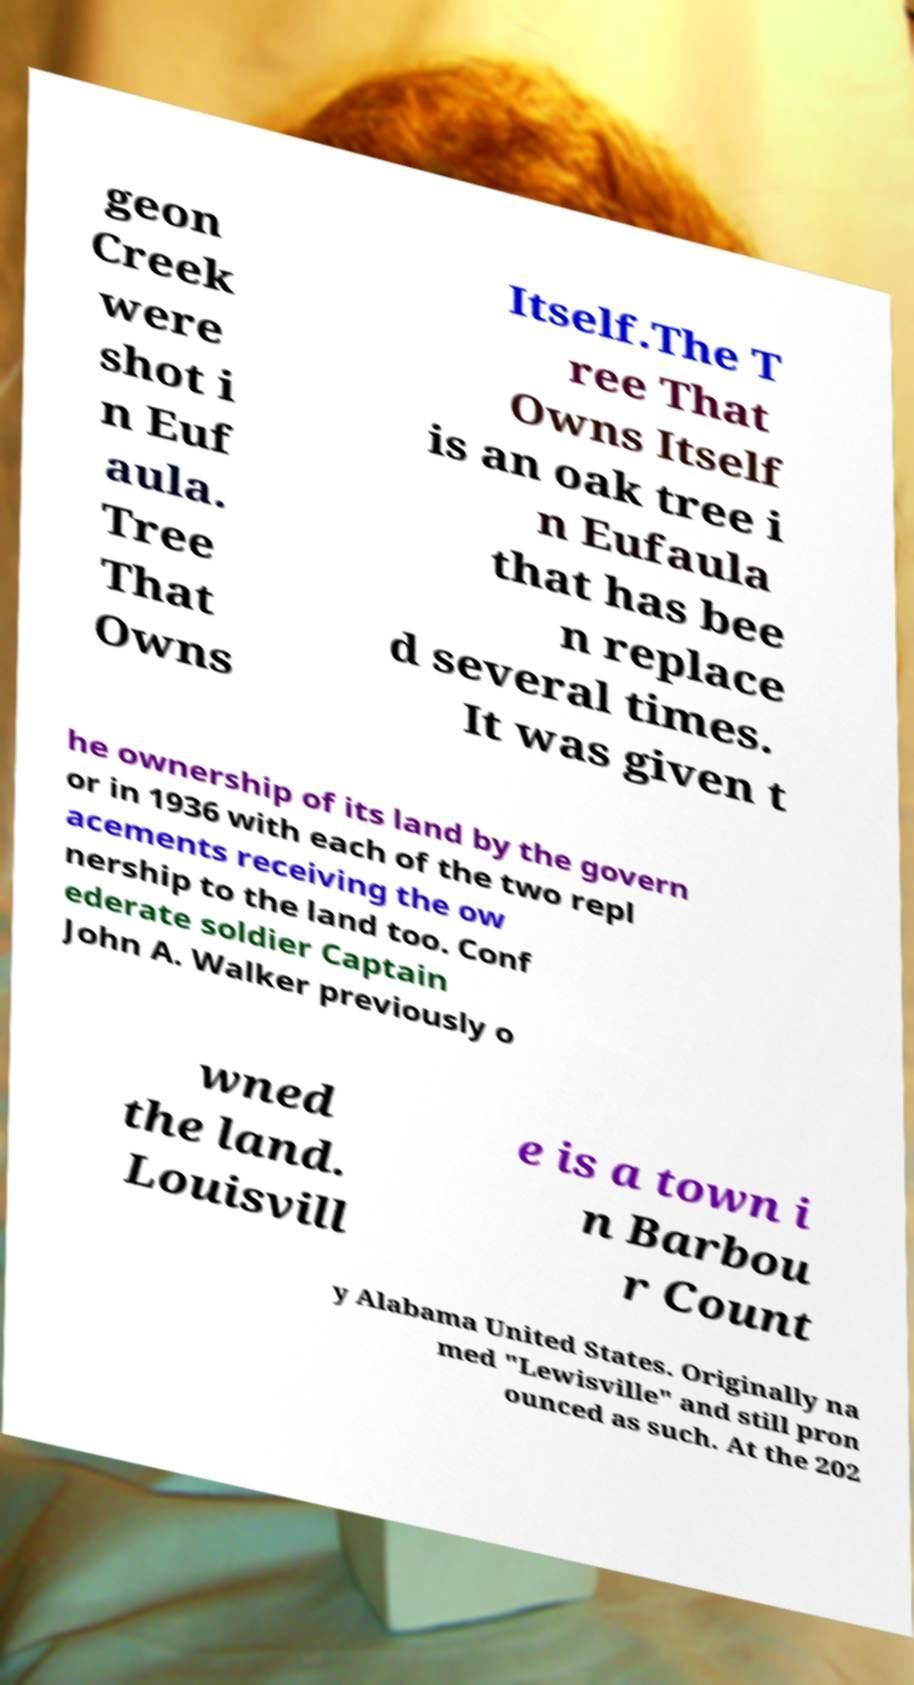Please read and relay the text visible in this image. What does it say? geon Creek were shot i n Euf aula. Tree That Owns Itself.The T ree That Owns Itself is an oak tree i n Eufaula that has bee n replace d several times. It was given t he ownership of its land by the govern or in 1936 with each of the two repl acements receiving the ow nership to the land too. Conf ederate soldier Captain John A. Walker previously o wned the land. Louisvill e is a town i n Barbou r Count y Alabama United States. Originally na med "Lewisville" and still pron ounced as such. At the 202 